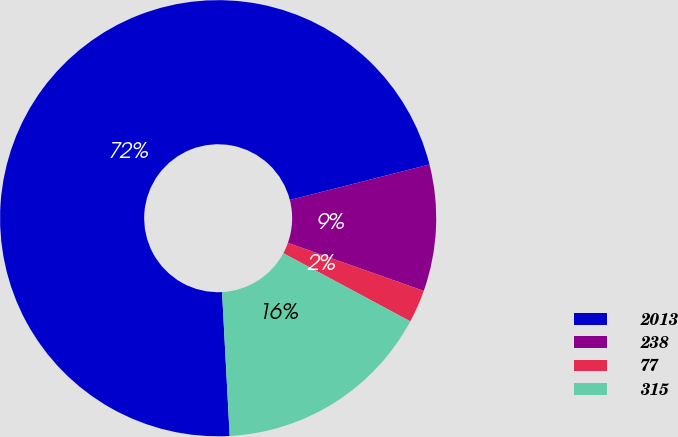<chart> <loc_0><loc_0><loc_500><loc_500><pie_chart><fcel>2013<fcel>238<fcel>77<fcel>315<nl><fcel>71.88%<fcel>9.37%<fcel>2.43%<fcel>16.32%<nl></chart> 